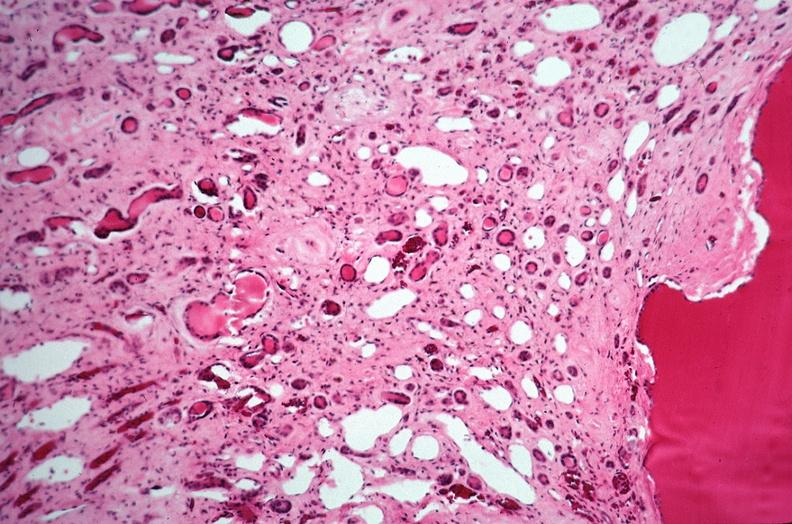where is this?
Answer the question using a single word or phrase. Urinary 